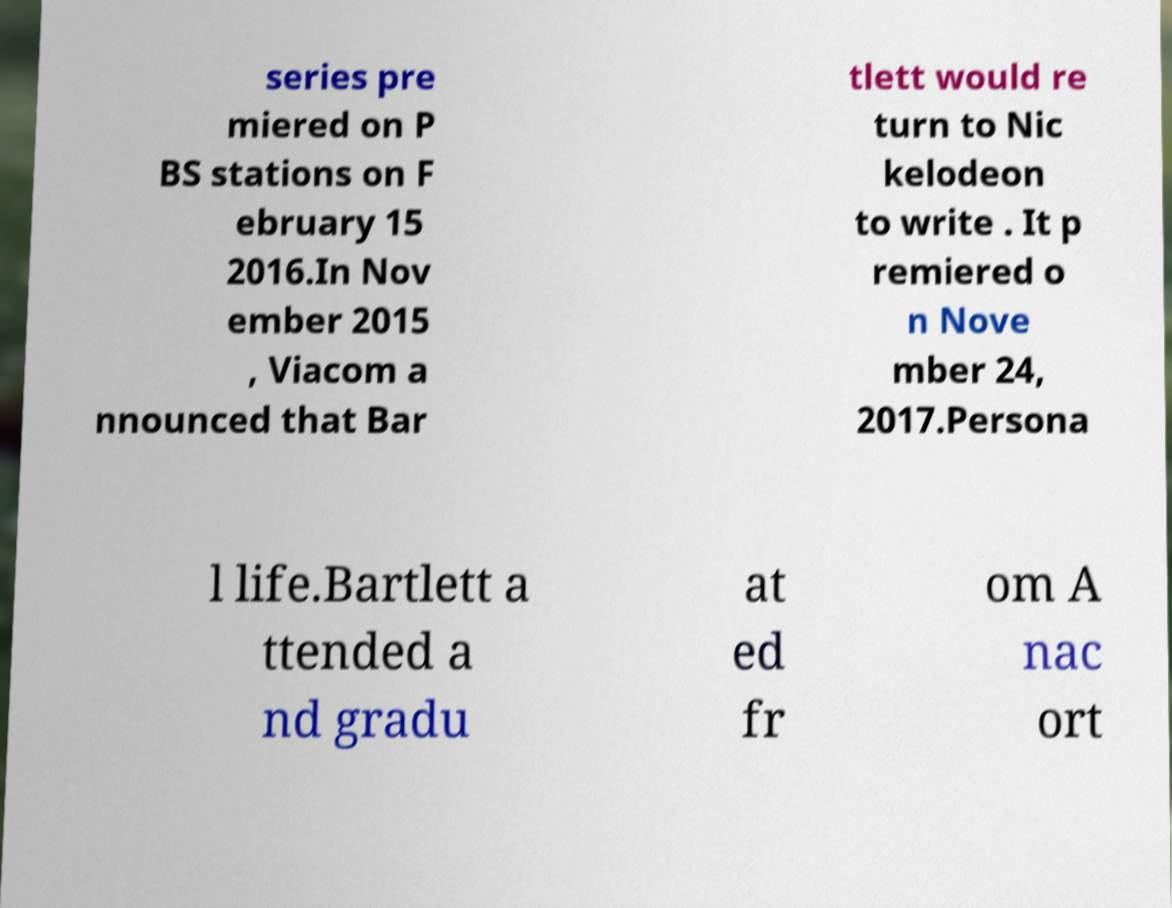Please identify and transcribe the text found in this image. series pre miered on P BS stations on F ebruary 15 2016.In Nov ember 2015 , Viacom a nnounced that Bar tlett would re turn to Nic kelodeon to write . It p remiered o n Nove mber 24, 2017.Persona l life.Bartlett a ttended a nd gradu at ed fr om A nac ort 